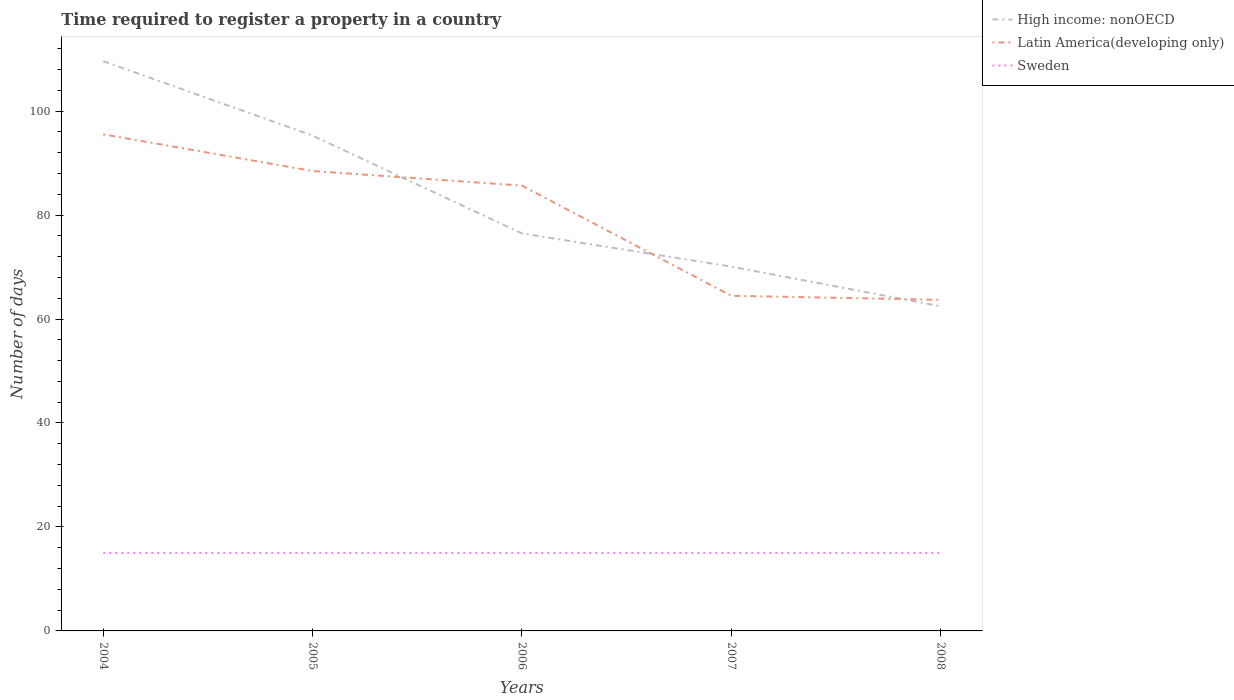Does the line corresponding to High income: nonOECD intersect with the line corresponding to Latin America(developing only)?
Your response must be concise. Yes. Across all years, what is the maximum number of days required to register a property in High income: nonOECD?
Provide a short and direct response. 62.46. What is the total number of days required to register a property in Latin America(developing only) in the graph?
Ensure brevity in your answer.  31.06. What is the difference between the highest and the second highest number of days required to register a property in Latin America(developing only)?
Give a very brief answer. 31.84. What is the difference between the highest and the lowest number of days required to register a property in Sweden?
Offer a very short reply. 0. How many years are there in the graph?
Your answer should be very brief. 5. What is the difference between two consecutive major ticks on the Y-axis?
Offer a terse response. 20. Are the values on the major ticks of Y-axis written in scientific E-notation?
Make the answer very short. No. Does the graph contain any zero values?
Your response must be concise. No. How many legend labels are there?
Keep it short and to the point. 3. What is the title of the graph?
Make the answer very short. Time required to register a property in a country. Does "Malawi" appear as one of the legend labels in the graph?
Your answer should be compact. No. What is the label or title of the Y-axis?
Your response must be concise. Number of days. What is the Number of days of High income: nonOECD in 2004?
Provide a succinct answer. 109.61. What is the Number of days in Latin America(developing only) in 2004?
Provide a succinct answer. 95.53. What is the Number of days of Sweden in 2004?
Give a very brief answer. 15. What is the Number of days in High income: nonOECD in 2005?
Offer a terse response. 95.29. What is the Number of days in Latin America(developing only) in 2005?
Offer a terse response. 88.48. What is the Number of days in Sweden in 2005?
Provide a succinct answer. 15. What is the Number of days in High income: nonOECD in 2006?
Make the answer very short. 76.47. What is the Number of days of Latin America(developing only) in 2006?
Keep it short and to the point. 85.67. What is the Number of days in Sweden in 2006?
Your answer should be very brief. 15. What is the Number of days in High income: nonOECD in 2007?
Your answer should be compact. 70.09. What is the Number of days in Latin America(developing only) in 2007?
Give a very brief answer. 64.48. What is the Number of days in High income: nonOECD in 2008?
Offer a very short reply. 62.46. What is the Number of days in Latin America(developing only) in 2008?
Give a very brief answer. 63.69. What is the Number of days in Sweden in 2008?
Provide a succinct answer. 15. Across all years, what is the maximum Number of days of High income: nonOECD?
Provide a short and direct response. 109.61. Across all years, what is the maximum Number of days in Latin America(developing only)?
Give a very brief answer. 95.53. Across all years, what is the maximum Number of days of Sweden?
Your answer should be compact. 15. Across all years, what is the minimum Number of days in High income: nonOECD?
Provide a short and direct response. 62.46. Across all years, what is the minimum Number of days in Latin America(developing only)?
Offer a very short reply. 63.69. Across all years, what is the minimum Number of days in Sweden?
Offer a terse response. 15. What is the total Number of days of High income: nonOECD in the graph?
Your response must be concise. 413.92. What is the total Number of days of Latin America(developing only) in the graph?
Keep it short and to the point. 397.84. What is the difference between the Number of days of High income: nonOECD in 2004 and that in 2005?
Provide a short and direct response. 14.32. What is the difference between the Number of days in Latin America(developing only) in 2004 and that in 2005?
Provide a short and direct response. 7.06. What is the difference between the Number of days in Sweden in 2004 and that in 2005?
Your answer should be very brief. 0. What is the difference between the Number of days in High income: nonOECD in 2004 and that in 2006?
Keep it short and to the point. 33.13. What is the difference between the Number of days in Latin America(developing only) in 2004 and that in 2006?
Ensure brevity in your answer.  9.87. What is the difference between the Number of days of High income: nonOECD in 2004 and that in 2007?
Offer a very short reply. 39.52. What is the difference between the Number of days of Latin America(developing only) in 2004 and that in 2007?
Provide a succinct answer. 31.06. What is the difference between the Number of days of Sweden in 2004 and that in 2007?
Make the answer very short. 0. What is the difference between the Number of days in High income: nonOECD in 2004 and that in 2008?
Keep it short and to the point. 47.15. What is the difference between the Number of days in Latin America(developing only) in 2004 and that in 2008?
Provide a succinct answer. 31.84. What is the difference between the Number of days of High income: nonOECD in 2005 and that in 2006?
Your response must be concise. 18.81. What is the difference between the Number of days of Latin America(developing only) in 2005 and that in 2006?
Your response must be concise. 2.81. What is the difference between the Number of days of High income: nonOECD in 2005 and that in 2007?
Your response must be concise. 25.2. What is the difference between the Number of days in Latin America(developing only) in 2005 and that in 2007?
Your answer should be compact. 24. What is the difference between the Number of days of Sweden in 2005 and that in 2007?
Your answer should be very brief. 0. What is the difference between the Number of days of High income: nonOECD in 2005 and that in 2008?
Make the answer very short. 32.83. What is the difference between the Number of days in Latin America(developing only) in 2005 and that in 2008?
Your answer should be very brief. 24.79. What is the difference between the Number of days in Sweden in 2005 and that in 2008?
Give a very brief answer. 0. What is the difference between the Number of days in High income: nonOECD in 2006 and that in 2007?
Offer a very short reply. 6.39. What is the difference between the Number of days of Latin America(developing only) in 2006 and that in 2007?
Offer a very short reply. 21.19. What is the difference between the Number of days of High income: nonOECD in 2006 and that in 2008?
Your answer should be compact. 14.02. What is the difference between the Number of days of Latin America(developing only) in 2006 and that in 2008?
Offer a terse response. 21.98. What is the difference between the Number of days of High income: nonOECD in 2007 and that in 2008?
Provide a short and direct response. 7.63. What is the difference between the Number of days of Latin America(developing only) in 2007 and that in 2008?
Provide a short and direct response. 0.79. What is the difference between the Number of days in Sweden in 2007 and that in 2008?
Ensure brevity in your answer.  0. What is the difference between the Number of days in High income: nonOECD in 2004 and the Number of days in Latin America(developing only) in 2005?
Give a very brief answer. 21.13. What is the difference between the Number of days in High income: nonOECD in 2004 and the Number of days in Sweden in 2005?
Your answer should be compact. 94.61. What is the difference between the Number of days of Latin America(developing only) in 2004 and the Number of days of Sweden in 2005?
Provide a short and direct response. 80.53. What is the difference between the Number of days of High income: nonOECD in 2004 and the Number of days of Latin America(developing only) in 2006?
Offer a very short reply. 23.94. What is the difference between the Number of days of High income: nonOECD in 2004 and the Number of days of Sweden in 2006?
Your answer should be very brief. 94.61. What is the difference between the Number of days of Latin America(developing only) in 2004 and the Number of days of Sweden in 2006?
Provide a succinct answer. 80.53. What is the difference between the Number of days of High income: nonOECD in 2004 and the Number of days of Latin America(developing only) in 2007?
Offer a very short reply. 45.13. What is the difference between the Number of days of High income: nonOECD in 2004 and the Number of days of Sweden in 2007?
Give a very brief answer. 94.61. What is the difference between the Number of days in Latin America(developing only) in 2004 and the Number of days in Sweden in 2007?
Your response must be concise. 80.53. What is the difference between the Number of days of High income: nonOECD in 2004 and the Number of days of Latin America(developing only) in 2008?
Give a very brief answer. 45.92. What is the difference between the Number of days in High income: nonOECD in 2004 and the Number of days in Sweden in 2008?
Offer a terse response. 94.61. What is the difference between the Number of days of Latin America(developing only) in 2004 and the Number of days of Sweden in 2008?
Provide a short and direct response. 80.53. What is the difference between the Number of days of High income: nonOECD in 2005 and the Number of days of Latin America(developing only) in 2006?
Offer a very short reply. 9.62. What is the difference between the Number of days in High income: nonOECD in 2005 and the Number of days in Sweden in 2006?
Offer a terse response. 80.29. What is the difference between the Number of days of Latin America(developing only) in 2005 and the Number of days of Sweden in 2006?
Your response must be concise. 73.48. What is the difference between the Number of days in High income: nonOECD in 2005 and the Number of days in Latin America(developing only) in 2007?
Your answer should be very brief. 30.81. What is the difference between the Number of days of High income: nonOECD in 2005 and the Number of days of Sweden in 2007?
Ensure brevity in your answer.  80.29. What is the difference between the Number of days in Latin America(developing only) in 2005 and the Number of days in Sweden in 2007?
Offer a very short reply. 73.48. What is the difference between the Number of days in High income: nonOECD in 2005 and the Number of days in Latin America(developing only) in 2008?
Keep it short and to the point. 31.6. What is the difference between the Number of days in High income: nonOECD in 2005 and the Number of days in Sweden in 2008?
Your answer should be compact. 80.29. What is the difference between the Number of days of Latin America(developing only) in 2005 and the Number of days of Sweden in 2008?
Provide a succinct answer. 73.48. What is the difference between the Number of days in High income: nonOECD in 2006 and the Number of days in Latin America(developing only) in 2007?
Your answer should be very brief. 12. What is the difference between the Number of days of High income: nonOECD in 2006 and the Number of days of Sweden in 2007?
Your answer should be compact. 61.48. What is the difference between the Number of days of Latin America(developing only) in 2006 and the Number of days of Sweden in 2007?
Give a very brief answer. 70.67. What is the difference between the Number of days in High income: nonOECD in 2006 and the Number of days in Latin America(developing only) in 2008?
Offer a terse response. 12.78. What is the difference between the Number of days of High income: nonOECD in 2006 and the Number of days of Sweden in 2008?
Offer a terse response. 61.48. What is the difference between the Number of days of Latin America(developing only) in 2006 and the Number of days of Sweden in 2008?
Your answer should be compact. 70.67. What is the difference between the Number of days of High income: nonOECD in 2007 and the Number of days of Latin America(developing only) in 2008?
Your response must be concise. 6.4. What is the difference between the Number of days in High income: nonOECD in 2007 and the Number of days in Sweden in 2008?
Keep it short and to the point. 55.09. What is the difference between the Number of days of Latin America(developing only) in 2007 and the Number of days of Sweden in 2008?
Ensure brevity in your answer.  49.48. What is the average Number of days of High income: nonOECD per year?
Your answer should be very brief. 82.78. What is the average Number of days of Latin America(developing only) per year?
Your answer should be compact. 79.57. In the year 2004, what is the difference between the Number of days of High income: nonOECD and Number of days of Latin America(developing only)?
Your answer should be compact. 14.07. In the year 2004, what is the difference between the Number of days in High income: nonOECD and Number of days in Sweden?
Make the answer very short. 94.61. In the year 2004, what is the difference between the Number of days of Latin America(developing only) and Number of days of Sweden?
Keep it short and to the point. 80.53. In the year 2005, what is the difference between the Number of days in High income: nonOECD and Number of days in Latin America(developing only)?
Offer a very short reply. 6.81. In the year 2005, what is the difference between the Number of days in High income: nonOECD and Number of days in Sweden?
Your answer should be compact. 80.29. In the year 2005, what is the difference between the Number of days of Latin America(developing only) and Number of days of Sweden?
Make the answer very short. 73.48. In the year 2006, what is the difference between the Number of days in High income: nonOECD and Number of days in Latin America(developing only)?
Offer a very short reply. -9.19. In the year 2006, what is the difference between the Number of days of High income: nonOECD and Number of days of Sweden?
Your answer should be very brief. 61.48. In the year 2006, what is the difference between the Number of days of Latin America(developing only) and Number of days of Sweden?
Provide a short and direct response. 70.67. In the year 2007, what is the difference between the Number of days in High income: nonOECD and Number of days in Latin America(developing only)?
Your answer should be very brief. 5.61. In the year 2007, what is the difference between the Number of days in High income: nonOECD and Number of days in Sweden?
Keep it short and to the point. 55.09. In the year 2007, what is the difference between the Number of days of Latin America(developing only) and Number of days of Sweden?
Give a very brief answer. 49.48. In the year 2008, what is the difference between the Number of days of High income: nonOECD and Number of days of Latin America(developing only)?
Give a very brief answer. -1.23. In the year 2008, what is the difference between the Number of days in High income: nonOECD and Number of days in Sweden?
Offer a terse response. 47.46. In the year 2008, what is the difference between the Number of days of Latin America(developing only) and Number of days of Sweden?
Offer a very short reply. 48.69. What is the ratio of the Number of days of High income: nonOECD in 2004 to that in 2005?
Keep it short and to the point. 1.15. What is the ratio of the Number of days in Latin America(developing only) in 2004 to that in 2005?
Ensure brevity in your answer.  1.08. What is the ratio of the Number of days in Sweden in 2004 to that in 2005?
Offer a terse response. 1. What is the ratio of the Number of days in High income: nonOECD in 2004 to that in 2006?
Your answer should be compact. 1.43. What is the ratio of the Number of days of Latin America(developing only) in 2004 to that in 2006?
Provide a succinct answer. 1.12. What is the ratio of the Number of days of Sweden in 2004 to that in 2006?
Give a very brief answer. 1. What is the ratio of the Number of days of High income: nonOECD in 2004 to that in 2007?
Give a very brief answer. 1.56. What is the ratio of the Number of days of Latin America(developing only) in 2004 to that in 2007?
Offer a very short reply. 1.48. What is the ratio of the Number of days in High income: nonOECD in 2004 to that in 2008?
Make the answer very short. 1.75. What is the ratio of the Number of days of High income: nonOECD in 2005 to that in 2006?
Your answer should be very brief. 1.25. What is the ratio of the Number of days of Latin America(developing only) in 2005 to that in 2006?
Your response must be concise. 1.03. What is the ratio of the Number of days of Sweden in 2005 to that in 2006?
Provide a short and direct response. 1. What is the ratio of the Number of days of High income: nonOECD in 2005 to that in 2007?
Make the answer very short. 1.36. What is the ratio of the Number of days of Latin America(developing only) in 2005 to that in 2007?
Your answer should be compact. 1.37. What is the ratio of the Number of days of Sweden in 2005 to that in 2007?
Provide a short and direct response. 1. What is the ratio of the Number of days of High income: nonOECD in 2005 to that in 2008?
Provide a short and direct response. 1.53. What is the ratio of the Number of days in Latin America(developing only) in 2005 to that in 2008?
Offer a very short reply. 1.39. What is the ratio of the Number of days of High income: nonOECD in 2006 to that in 2007?
Provide a short and direct response. 1.09. What is the ratio of the Number of days in Latin America(developing only) in 2006 to that in 2007?
Give a very brief answer. 1.33. What is the ratio of the Number of days in High income: nonOECD in 2006 to that in 2008?
Give a very brief answer. 1.22. What is the ratio of the Number of days in Latin America(developing only) in 2006 to that in 2008?
Your answer should be very brief. 1.34. What is the ratio of the Number of days of Sweden in 2006 to that in 2008?
Make the answer very short. 1. What is the ratio of the Number of days in High income: nonOECD in 2007 to that in 2008?
Your answer should be compact. 1.12. What is the ratio of the Number of days of Latin America(developing only) in 2007 to that in 2008?
Provide a succinct answer. 1.01. What is the difference between the highest and the second highest Number of days of High income: nonOECD?
Provide a short and direct response. 14.32. What is the difference between the highest and the second highest Number of days of Latin America(developing only)?
Offer a very short reply. 7.06. What is the difference between the highest and the second highest Number of days of Sweden?
Offer a terse response. 0. What is the difference between the highest and the lowest Number of days in High income: nonOECD?
Provide a succinct answer. 47.15. What is the difference between the highest and the lowest Number of days of Latin America(developing only)?
Your response must be concise. 31.84. What is the difference between the highest and the lowest Number of days of Sweden?
Ensure brevity in your answer.  0. 